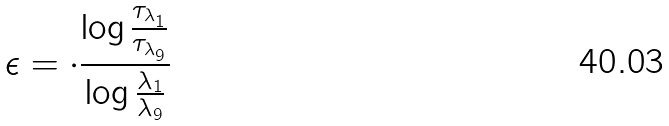Convert formula to latex. <formula><loc_0><loc_0><loc_500><loc_500>\epsilon = \cdot \frac { \log \frac { \tau _ { \lambda _ { 1 } } } { \tau _ { \lambda _ { 9 } } } } { \log \frac { \lambda _ { 1 } } { \lambda _ { 9 } } }</formula> 